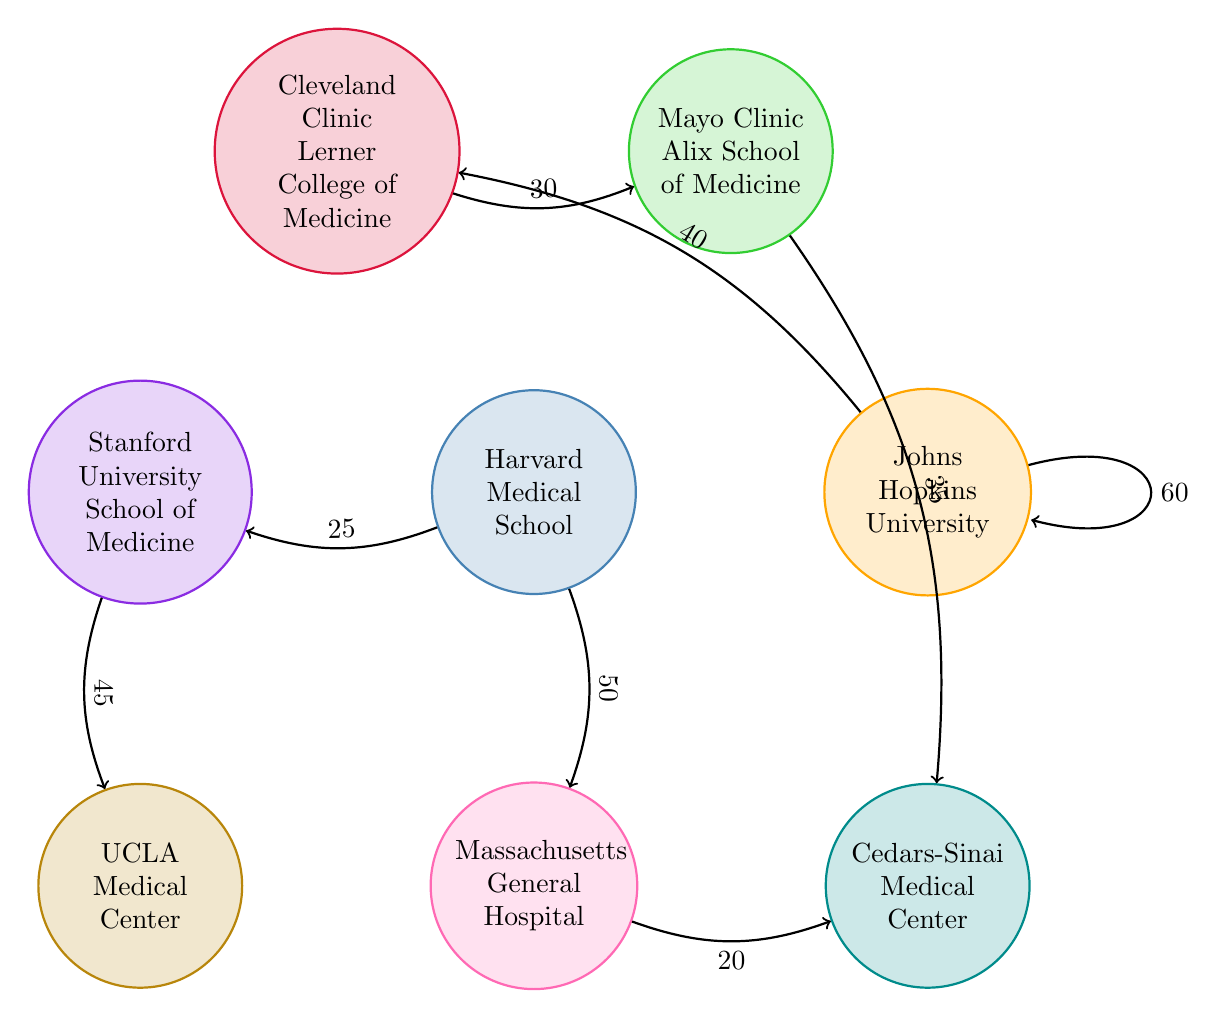What is the placement success value from Harvard Medical School to Massachusetts General Hospital? The diagram shows a directed edge from Harvard Medical School to Massachusetts General Hospital with a value of 50. This indicates the level of job placement success associated with that training program and hospital.
Answer: 50 Which medical school has the highest job placement connection to itself? The diagram indicates that Johns Hopkins University has a self-loop that represents its job placement success to its associated hospital, Johns Hopkins University Hospital, with a value of 60. This is the highest among all connections.
Answer: 60 What is the connection value between Mayo Clinic Alix School of Medicine and Cedars-Sinai Medical Center? Observing the diagram, there is a directed connection from Mayo Clinic Alix School of Medicine to Cedars-Sinai Medical Center with a job placement value of 35.
Answer: 35 How many nodes are present in the diagram? A review of the nodes in the diagram shows there are a total of eight distinct training programs and hospitals represented, indicating the network being analyzed.
Answer: 8 Which two training programs have a bi-directional connection? The diagram displays a bi-directional connection between Cleveland Clinic Lerner College of Medicine and Mayo Clinic Alix School of Medicine, with placement values of 30 in both directions.
Answer: Cleveland Clinic Lerner College of Medicine and Mayo Clinic Alix School of Medicine What is the lowest placement value from Massachusetts General Hospital to another medical center? The diagram illustrates a connection from Massachusetts General Hospital to Cedars-Sinai Medical Center with a placement success value of 20, which is the lowest value observed for outward connections from this hospital.
Answer: 20 Which training program has a connection value to two hospitals and what are those values? Harvard Medical School connects to both Massachusetts General Hospital and Stanford University School of Medicine with values of 50 and 25 respectively. This indicates its reach to multiple job placements.
Answer: 50 and 25 How does the diagram visually represent job placement flows? The flows are shown as directed arrows between nodes (training programs and hospitals), with the thickness or weight of the arrows indicating the strength of the connection, which is the associated job placement success.
Answer: Directed arrows 